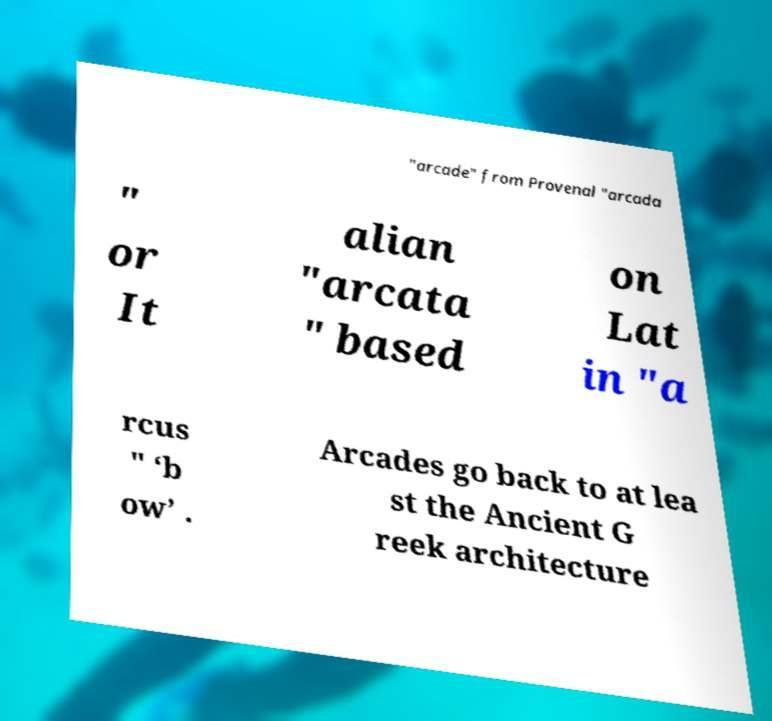Can you read and provide the text displayed in the image?This photo seems to have some interesting text. Can you extract and type it out for me? "arcade" from Provenal "arcada " or It alian "arcata " based on Lat in "a rcus " ‘b ow’ . Arcades go back to at lea st the Ancient G reek architecture 